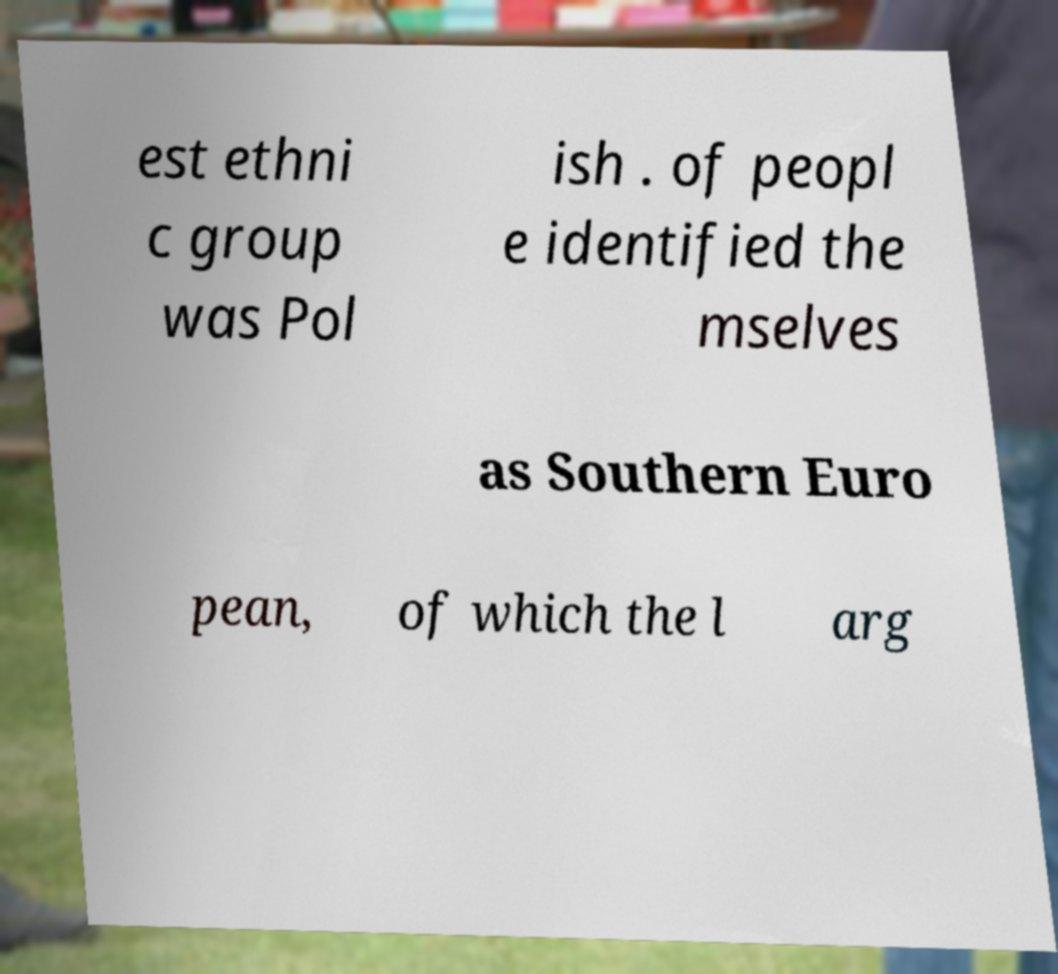There's text embedded in this image that I need extracted. Can you transcribe it verbatim? est ethni c group was Pol ish . of peopl e identified the mselves as Southern Euro pean, of which the l arg 